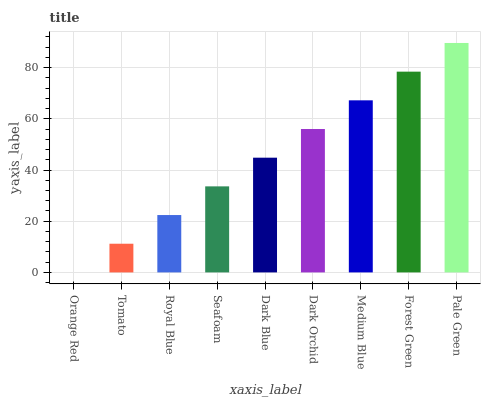Is Orange Red the minimum?
Answer yes or no. Yes. Is Pale Green the maximum?
Answer yes or no. Yes. Is Tomato the minimum?
Answer yes or no. No. Is Tomato the maximum?
Answer yes or no. No. Is Tomato greater than Orange Red?
Answer yes or no. Yes. Is Orange Red less than Tomato?
Answer yes or no. Yes. Is Orange Red greater than Tomato?
Answer yes or no. No. Is Tomato less than Orange Red?
Answer yes or no. No. Is Dark Blue the high median?
Answer yes or no. Yes. Is Dark Blue the low median?
Answer yes or no. Yes. Is Medium Blue the high median?
Answer yes or no. No. Is Tomato the low median?
Answer yes or no. No. 